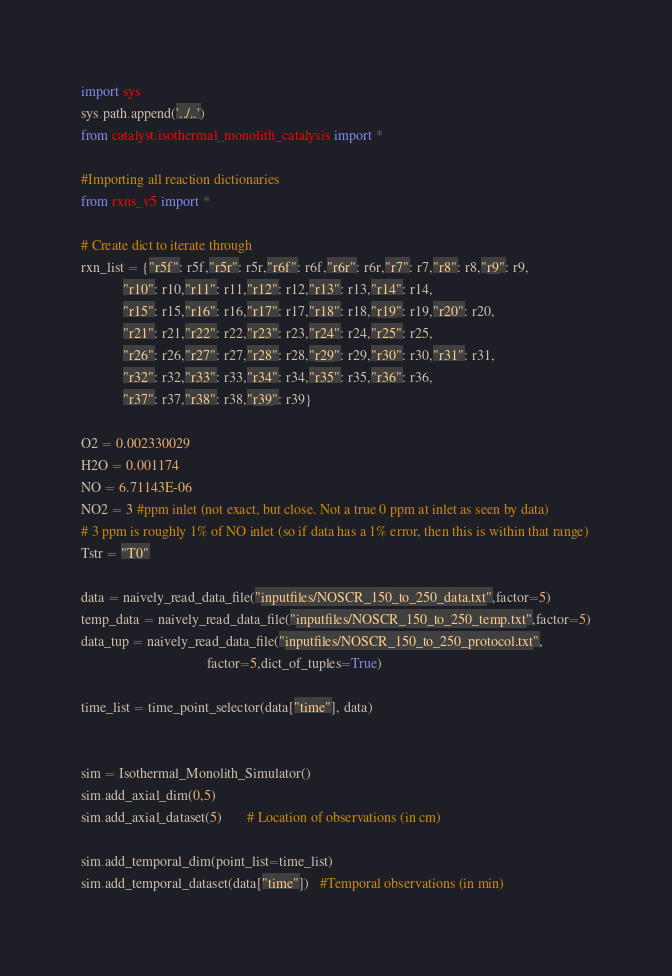<code> <loc_0><loc_0><loc_500><loc_500><_Python_>import sys
sys.path.append('../..')
from catalyst.isothermal_monolith_catalysis import *

#Importing all reaction dictionaries
from rxns_v5 import *

# Create dict to iterate through
rxn_list = {"r5f": r5f,"r5r": r5r,"r6f": r6f,"r6r": r6r,"r7": r7,"r8": r8,"r9": r9,
            "r10": r10,"r11": r11,"r12": r12,"r13": r13,"r14": r14,
            "r15": r15,"r16": r16,"r17": r17,"r18": r18,"r19": r19,"r20": r20,
            "r21": r21,"r22": r22,"r23": r23,"r24": r24,"r25": r25,
            "r26": r26,"r27": r27,"r28": r28,"r29": r29,"r30": r30,"r31": r31,
            "r32": r32,"r33": r33,"r34": r34,"r35": r35,"r36": r36,
            "r37": r37,"r38": r38,"r39": r39}

O2 = 0.002330029
H2O = 0.001174
NO = 6.71143E-06
NO2 = 3 #ppm inlet (not exact, but close. Not a true 0 ppm at inlet as seen by data)
# 3 ppm is roughly 1% of NO inlet (so if data has a 1% error, then this is within that range)
Tstr = "T0"

data = naively_read_data_file("inputfiles/NOSCR_150_to_250_data.txt",factor=5)
temp_data = naively_read_data_file("inputfiles/NOSCR_150_to_250_temp.txt",factor=5)
data_tup = naively_read_data_file("inputfiles/NOSCR_150_to_250_protocol.txt",
                                    factor=5,dict_of_tuples=True)

time_list = time_point_selector(data["time"], data)


sim = Isothermal_Monolith_Simulator()
sim.add_axial_dim(0,5)
sim.add_axial_dataset(5)       # Location of observations (in cm)

sim.add_temporal_dim(point_list=time_list)
sim.add_temporal_dataset(data["time"])   #Temporal observations (in min)
</code> 